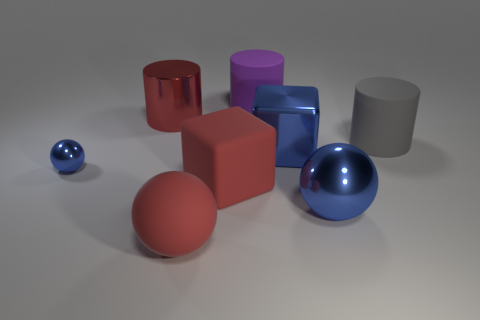Are the cylinder to the right of the purple object and the red block made of the same material?
Provide a succinct answer. Yes. There is a large object that is to the left of the big red cube and in front of the shiny cube; what color is it?
Keep it short and to the point. Red. There is a blue metal object to the left of the large rubber ball; how many large purple cylinders are in front of it?
Your answer should be very brief. 0. What is the material of the gray object that is the same shape as the purple matte object?
Offer a very short reply. Rubber. The metallic cube is what color?
Give a very brief answer. Blue. What number of things are large yellow metallic things or purple things?
Make the answer very short. 1. What is the shape of the tiny blue metallic object that is left of the large matte cylinder that is on the right side of the purple rubber cylinder?
Provide a short and direct response. Sphere. How many other things are the same material as the tiny blue ball?
Offer a very short reply. 3. Do the big red block and the big thing to the left of the big red rubber ball have the same material?
Ensure brevity in your answer.  No. How many things are either metal spheres left of the large matte ball or big rubber things to the right of the large red matte block?
Your answer should be very brief. 3. 